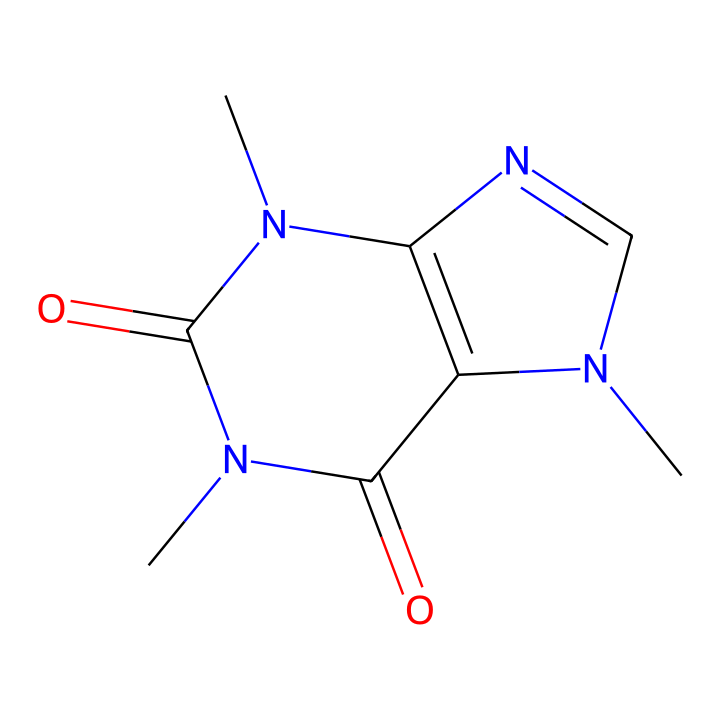What is the molecular formula of caffeine? To determine the molecular formula from the SMILES structure, we count the number of each type of atom present in the representation. The SMILES indicates multiple nitrogen (N), carbon (C), and oxygen (O) atoms. Specifically, there are 8 carbon atoms, 10 hydrogen atoms, 4 nitrogen atoms, and 2 oxygen atoms, leading to the formula C8H10N4O2.
Answer: C8H10N4O2 How many rings are in the structure of caffeine? By analyzing the structure, we can observe the cyclic portions, which are indicated by the presence of numbers (1 and 2) in the SMILES. These numbers show that two rings are fused together in the molecule.
Answer: 2 What type of bonding is primarily present in the caffeine structure? The structure of caffeine includes carbon-nitrogen and carbon-carbon bonds as well as carbon-oxygen double bonds. The primary types of bonding indicated in the SMILES are covalent bonds.
Answer: covalent Which element makes caffeine a member of alkaloids? The nitrogen atoms present in the structure are key characteristics that classify caffeine as an alkaloid. Alkaloids are defined by the presence of nitrogen atoms in their structures.
Answer: nitrogen What is the significance of the N-atom positions in the caffeine molecule? The placement of the nitrogen atoms in the structure affects caffeine's physiological properties, such as its ability to bind to specific receptors in the human body and its psychoactive effects. The positions of the N-atoms can alter the overall molecular polarity and biological activity.
Answer: physiological effects What is the role of the oxygen atoms in caffeine? The oxygen atoms in caffeine are involved in forming carbonyl groups (C=O) that contribute to the stability of the molecule and influence its solubility in water, which is significant for its absorption in the body.
Answer: stability and solubility How does caffeine's structure contribute to its stimulant properties? The presence of nitrogen atoms and the arrangement of atoms allow caffeine to interact with adenosine receptors in the brain, resulting in increased alertness and reduced fatigue. The molecular structure facilitates specific binding to these receptors, enhancing its stimulant effects.
Answer: increased alertness 